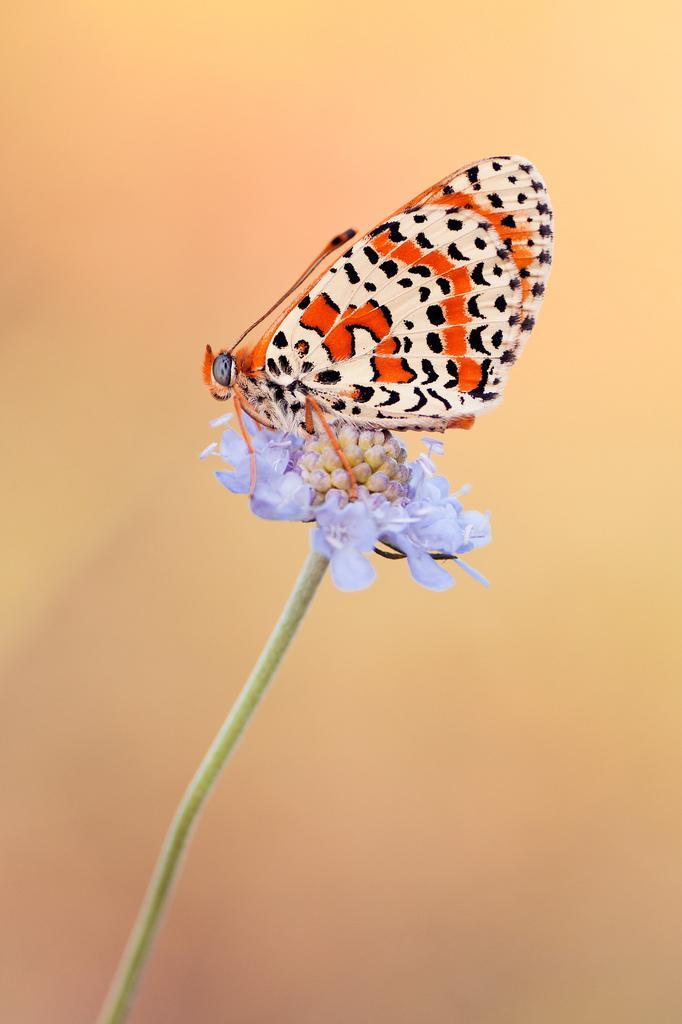What is the main subject of the image? There is a butterfly in the image. Where is the butterfly located in the image? The butterfly is sitting on a flower. Can you describe the background of the image? The background of the image is blurred. What type of agreement is being signed by the butterfly in the image? There is no agreement or signing activity present in the image; it features a butterfly sitting on a flower. Is there any poison visible in the image? There is no poison present in the image; it features a butterfly sitting on a flower. 